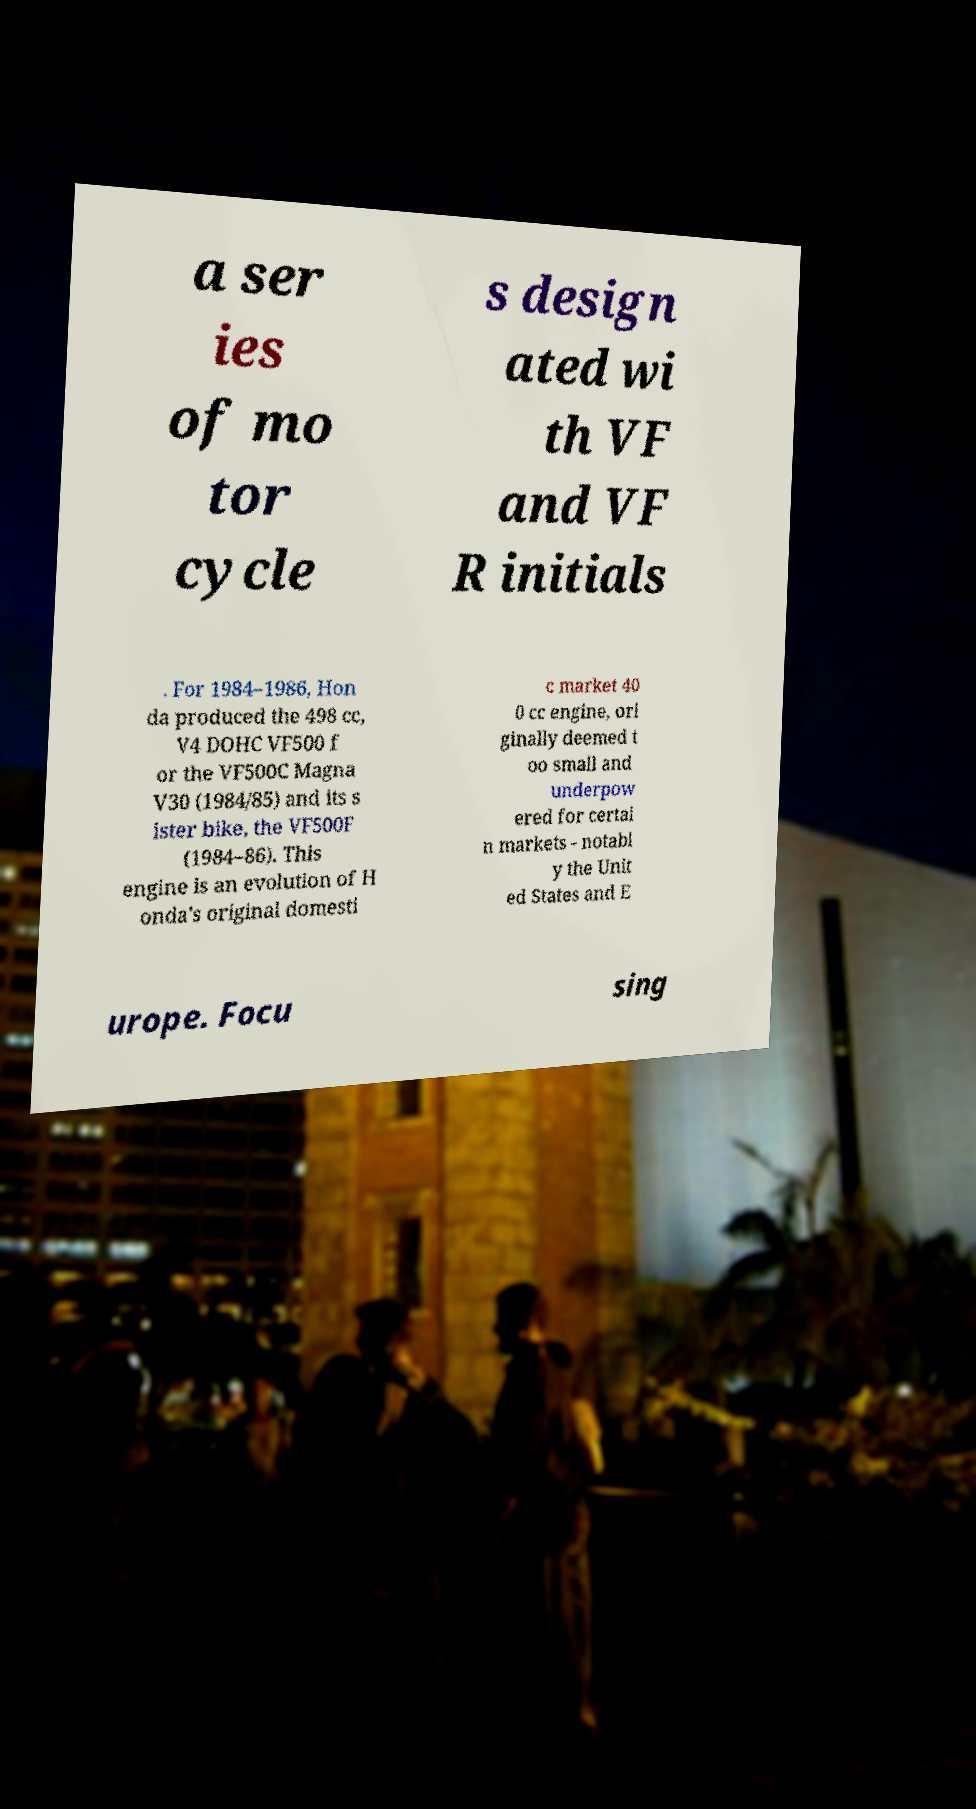Could you extract and type out the text from this image? a ser ies of mo tor cycle s design ated wi th VF and VF R initials . For 1984–1986, Hon da produced the 498 cc, V4 DOHC VF500 f or the VF500C Magna V30 (1984/85) and its s ister bike, the VF500F (1984–86). This engine is an evolution of H onda's original domesti c market 40 0 cc engine, ori ginally deemed t oo small and underpow ered for certai n markets - notabl y the Unit ed States and E urope. Focu sing 